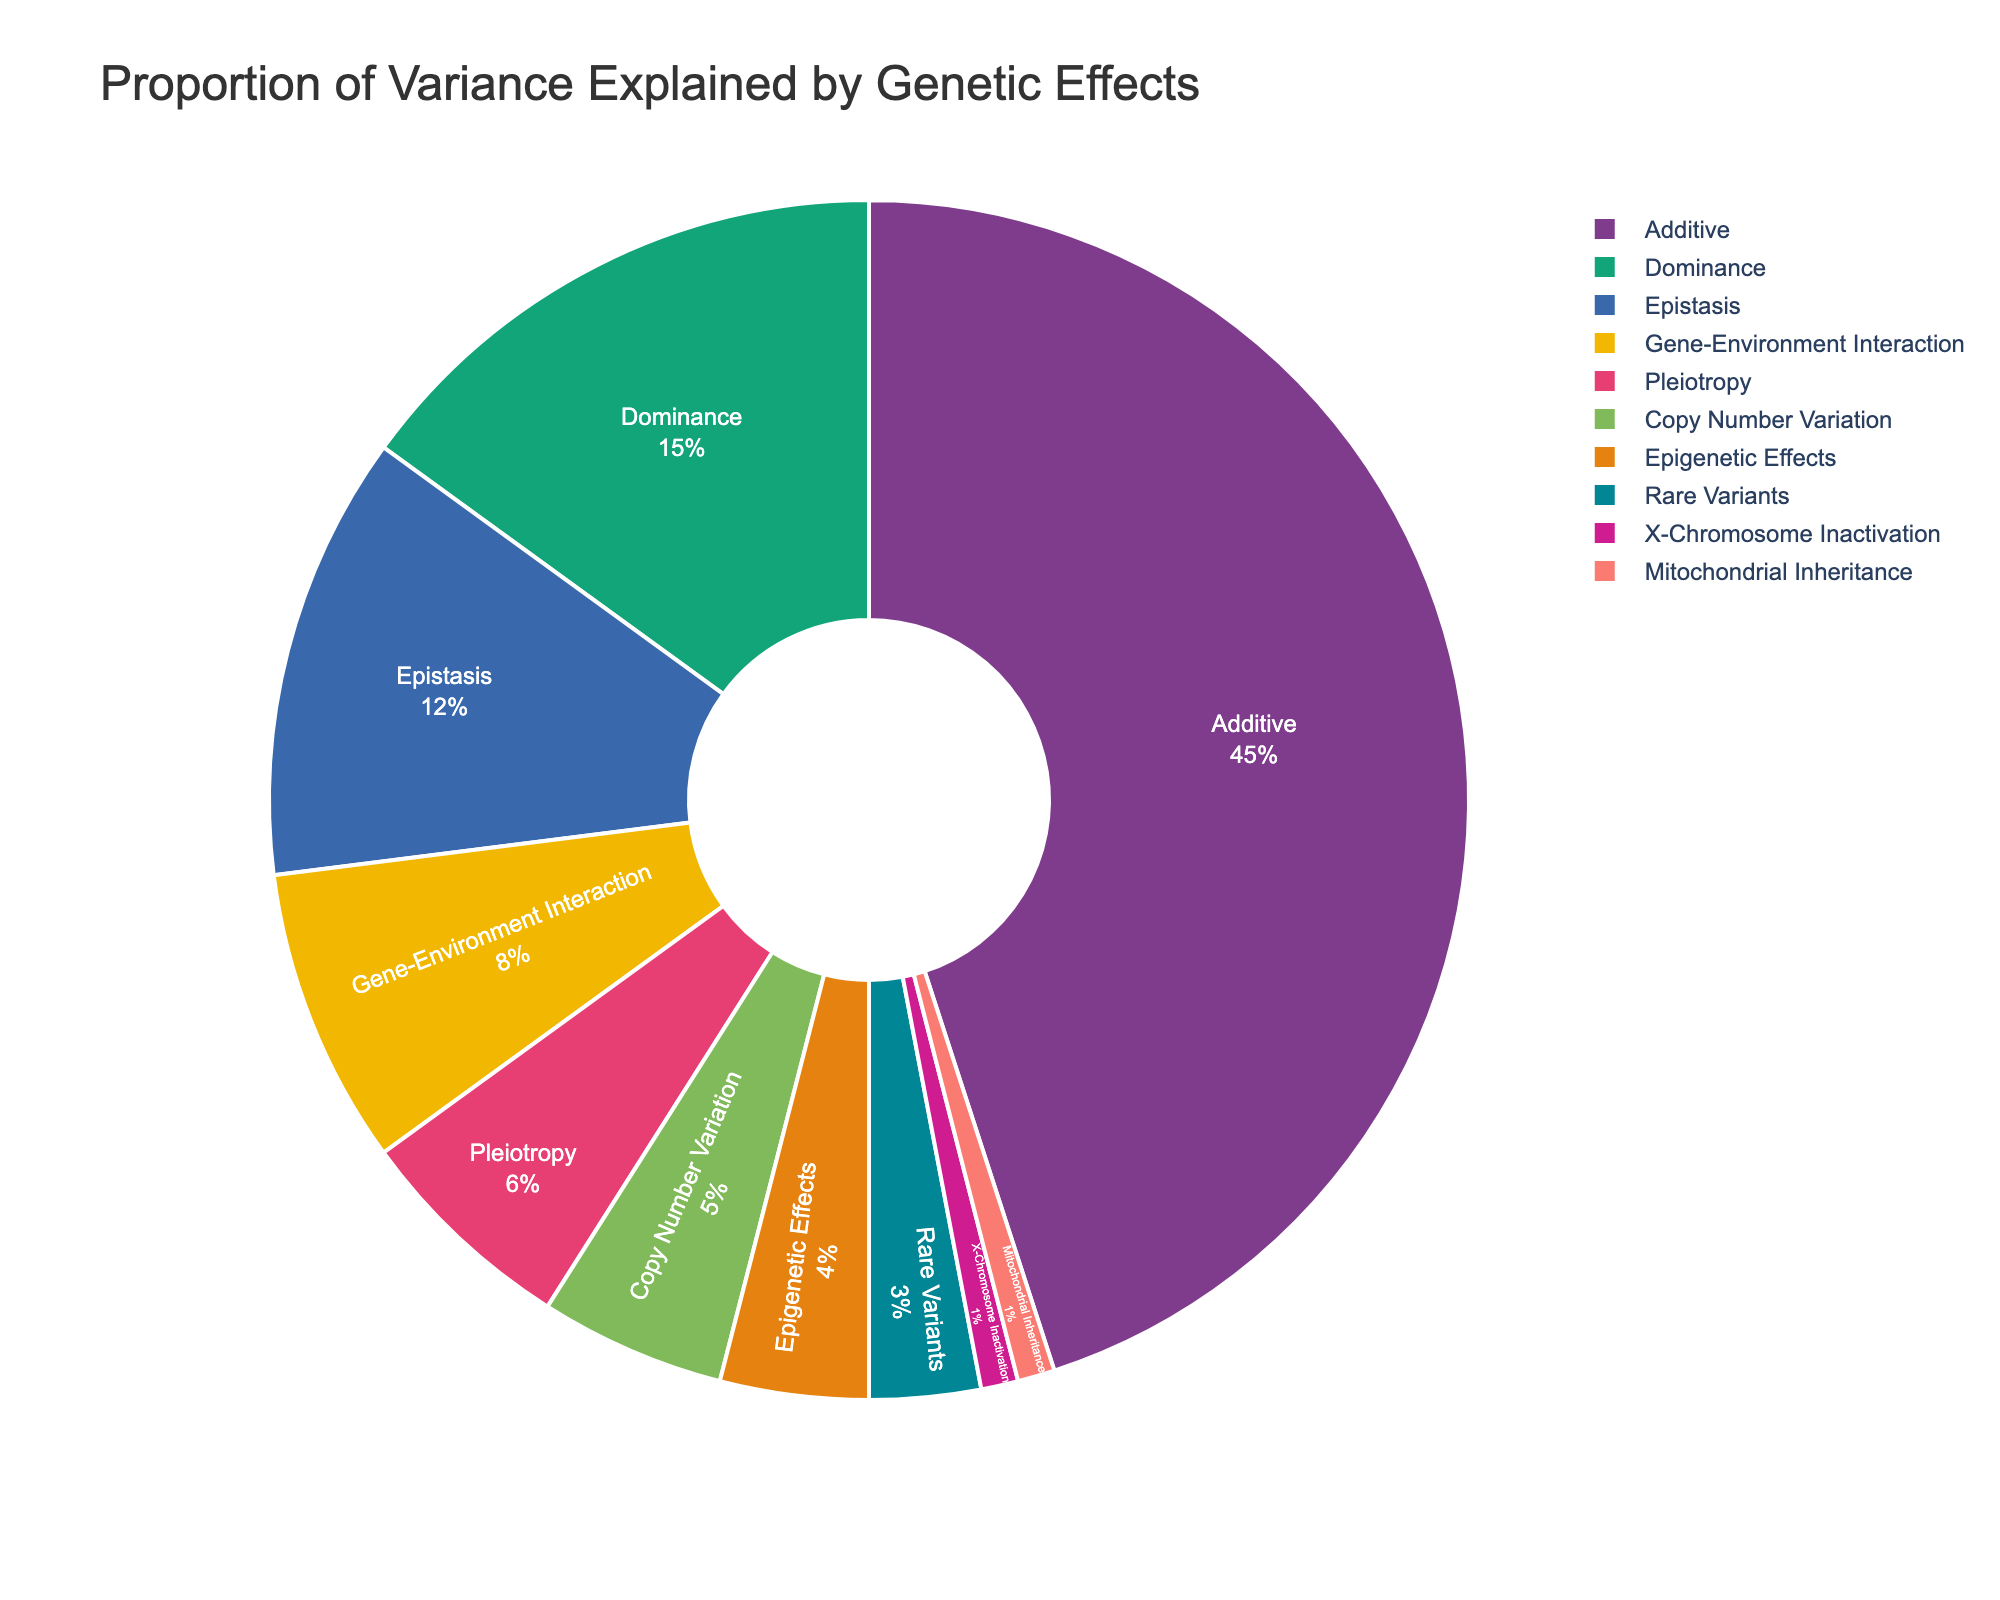What's the genetic effect that explains the largest proportion of variance? The chart shows different genetic effects and their corresponding proportions of variance explained. The largest segment is labeled "Additive" with 45%.
Answer: Additive Which genetic effect explains the smallest proportion of variance? By looking at the smallest segment in the pie chart, the "X-Chromosome Inactivation" and "Mitochondrial Inheritance" both explain the smallest proportion, with 1% each.
Answer: X-Chromosome Inactivation, Mitochondrial Inheritance What is the combined proportion of variance explained by Epigenetic Effects and Rare Variants? The chart shows that Epigenetic Effects explain 4% and Rare Variants explain 3%. Adding these two together gives 4% + 3% = 7%.
Answer: 7% Compare the proportion of variance explained by Dominance and Epistasis. Which one is greater? The chart shows that Dominance explains 15% of the variance while Epistasis explains 12%. Thus, Dominance explains a greater proportion than Epistasis.
Answer: Dominance How much more variance does Additive explain compared to Copy Number Variation? The chart shows that Additive explains 45% and Copy Number Variation explains 5%. The difference is 45% - 5% = 40%.
Answer: 40% Which genetic effects collectively explain more than half of the total variance? By summing the proportions of each genetic effect: Additive (45%), Dominance (15%), and Epistasis (12%) together is 45% + 15% + 12% = 72%, which is already above half. Only these three are needed.
Answer: Additive, Dominance, Epistasis What is the combined effect of Gene-Environment Interaction and Pleiotropy on the variance? The chart shows that Gene-Environment Interaction explains 8% and Pleiotropy explains 6%. Adding these two together gives 8% + 6% = 14%.
Answer: 14% Is the proportion of variance explained by Copy Number Variation more or less than half of that explained by Dominance? Dominance explains 15% of the variance, while Copy Number Variation explains 5%. Half of Dominance is 7.5%, and since 5% is less than 7.5%, Copy Number Variation explains less.
Answer: Less Which genetic effect is represented by the second largest segment in the pie chart? The second largest segment is labeled "Dominance" which explains 15% of the variance.
Answer: Dominance 